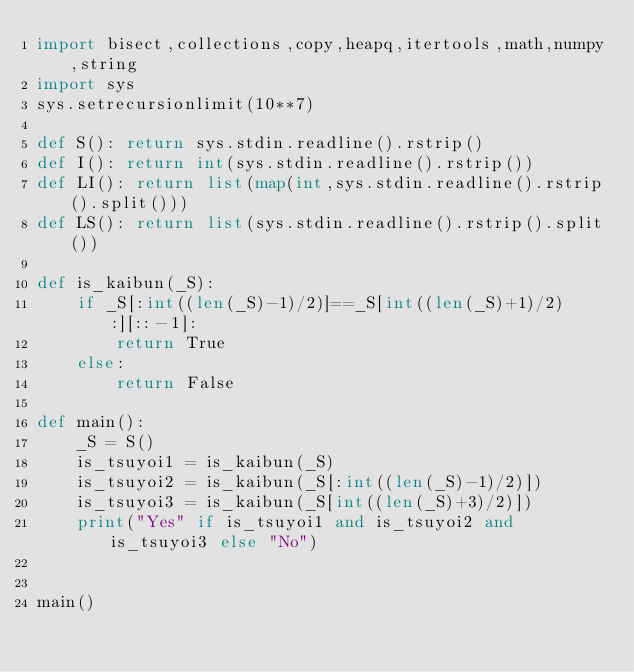<code> <loc_0><loc_0><loc_500><loc_500><_Python_>import bisect,collections,copy,heapq,itertools,math,numpy,string
import sys
sys.setrecursionlimit(10**7)

def S(): return sys.stdin.readline().rstrip()
def I(): return int(sys.stdin.readline().rstrip())
def LI(): return list(map(int,sys.stdin.readline().rstrip().split()))
def LS(): return list(sys.stdin.readline().rstrip().split())

def is_kaibun(_S):
    if _S[:int((len(_S)-1)/2)]==_S[int((len(_S)+1)/2):][::-1]:
        return True
    else:
        return False

def main():
    _S = S()
    is_tsuyoi1 = is_kaibun(_S)
    is_tsuyoi2 = is_kaibun(_S[:int((len(_S)-1)/2)])
    is_tsuyoi3 = is_kaibun(_S[int((len(_S)+3)/2)])
    print("Yes" if is_tsuyoi1 and is_tsuyoi2 and is_tsuyoi3 else "No")


main()
</code> 